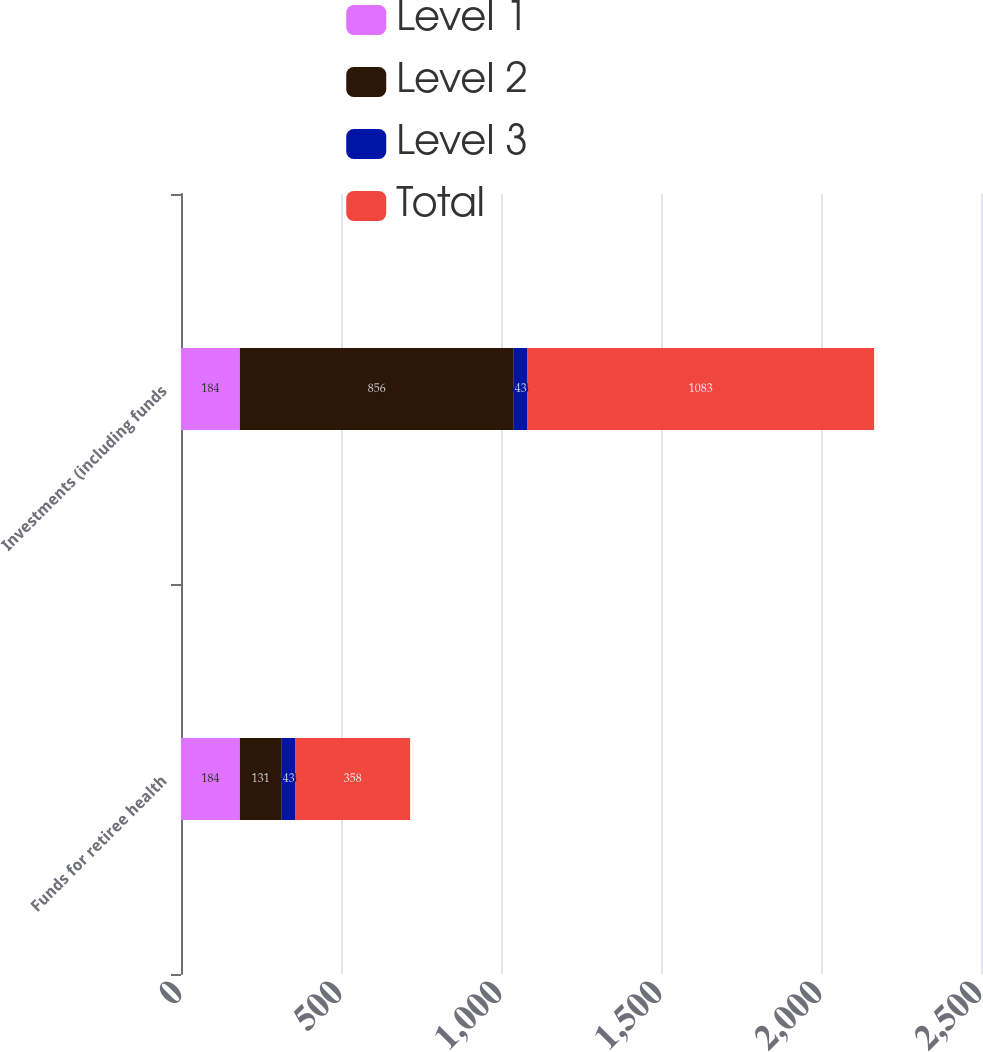Convert chart. <chart><loc_0><loc_0><loc_500><loc_500><stacked_bar_chart><ecel><fcel>Funds for retiree health<fcel>Investments (including funds<nl><fcel>Level 1<fcel>184<fcel>184<nl><fcel>Level 2<fcel>131<fcel>856<nl><fcel>Level 3<fcel>43<fcel>43<nl><fcel>Total<fcel>358<fcel>1083<nl></chart> 